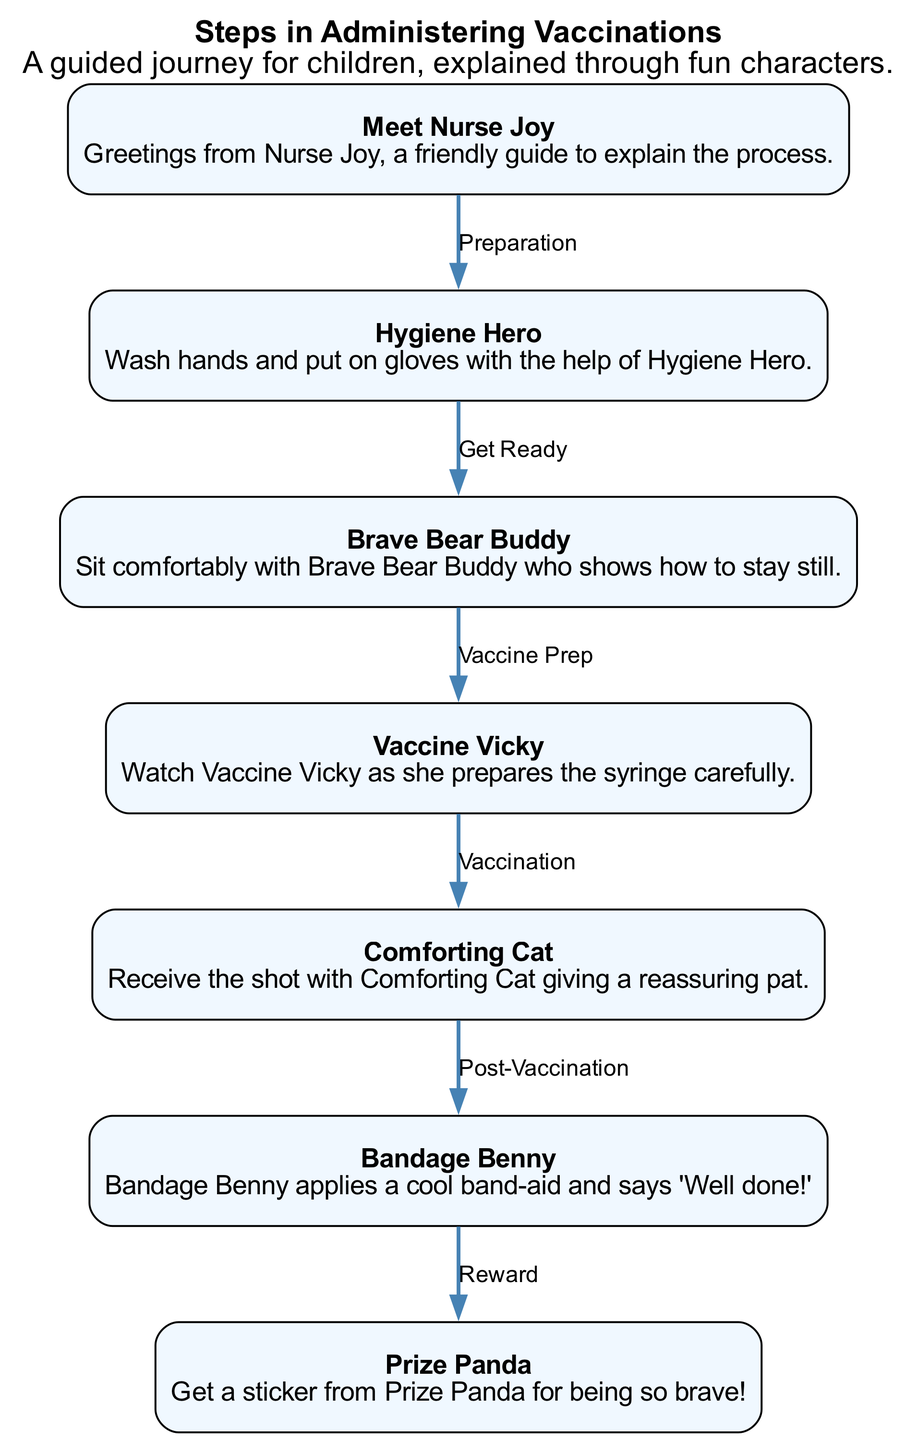What character introduces the vaccination process? The diagram begins with Nurse Joy, who greets the children and introduces them to the vaccination process. This is the starting point of the journey, clearly stated in step 1.
Answer: Nurse Joy How many characters guide the vaccination steps? There are a total of seven characters, each representing different steps in the vaccination process; this can be counted directly from the nodes in the diagram.
Answer: Seven What is the role of Brave Bear Buddy? Brave Bear Buddy helps children sit comfortably and teaches them how to stay still during the vaccination process, as described in step 3.
Answer: Stay still Which character prepares the syringe? Vaccine Vicky is responsible for preparing the syringe carefully, as indicated in step 4 of the sequence.
Answer: Vaccine Vicky What happens after receiving the shot? After the vaccination is administered, the next step involves post-vaccination care with Bandage Benny applying a band-aid, as indicated by the edge leading from Comforting Cat to Bandage Benny.
Answer: Bandage Benny What is the final reward for children? The final reward for children after the vaccination process is a sticker from Prize Panda, as shown in the last step of the diagram.
Answer: Sticker What step comes immediately before "Bandage Benny"? The step that comes immediately before "Bandage Benny" is "Comforting Cat," who provides reassurance after the vaccination. This is determined by looking at the sequence of edges leading from one character to the next, especially the edge connecting step 5 to step 6.
Answer: Comforting Cat What action does Hygiene Hero emphasize? Hygiene Hero emphasizes the action of washing hands and putting on gloves as part of the preparation for the vaccination, described in step 2.
Answer: Wash hands 